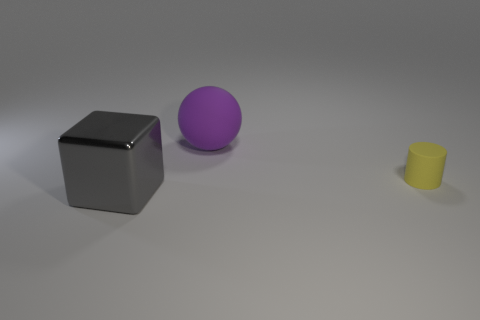Add 1 tiny cylinders. How many objects exist? 4 Subtract all spheres. How many objects are left? 2 Subtract all cyan cubes. Subtract all big purple spheres. How many objects are left? 2 Add 2 big matte spheres. How many big matte spheres are left? 3 Add 3 small brown rubber cylinders. How many small brown rubber cylinders exist? 3 Subtract 0 green blocks. How many objects are left? 3 Subtract all blue cylinders. Subtract all red spheres. How many cylinders are left? 1 